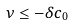<formula> <loc_0><loc_0><loc_500><loc_500>\nu \leq - \delta c _ { 0 }</formula> 